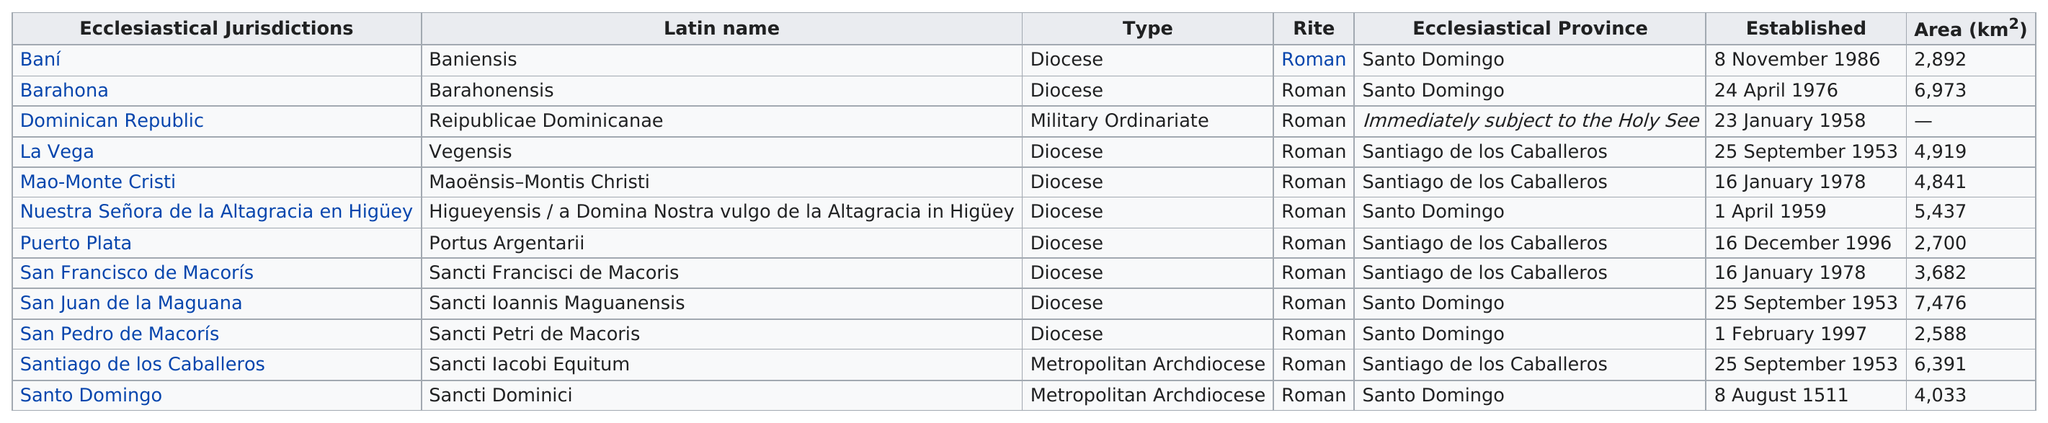Outline some significant characteristics in this image. Diocese is the type of organization that appears most frequently. The Dominican Republic does not have a given area. Santo Domingo was the only diocese established before 1900. San Pedro de Macorís is located in the diocese with the smallest area. The Santo Domingo province has a total of 6 dioceses. 